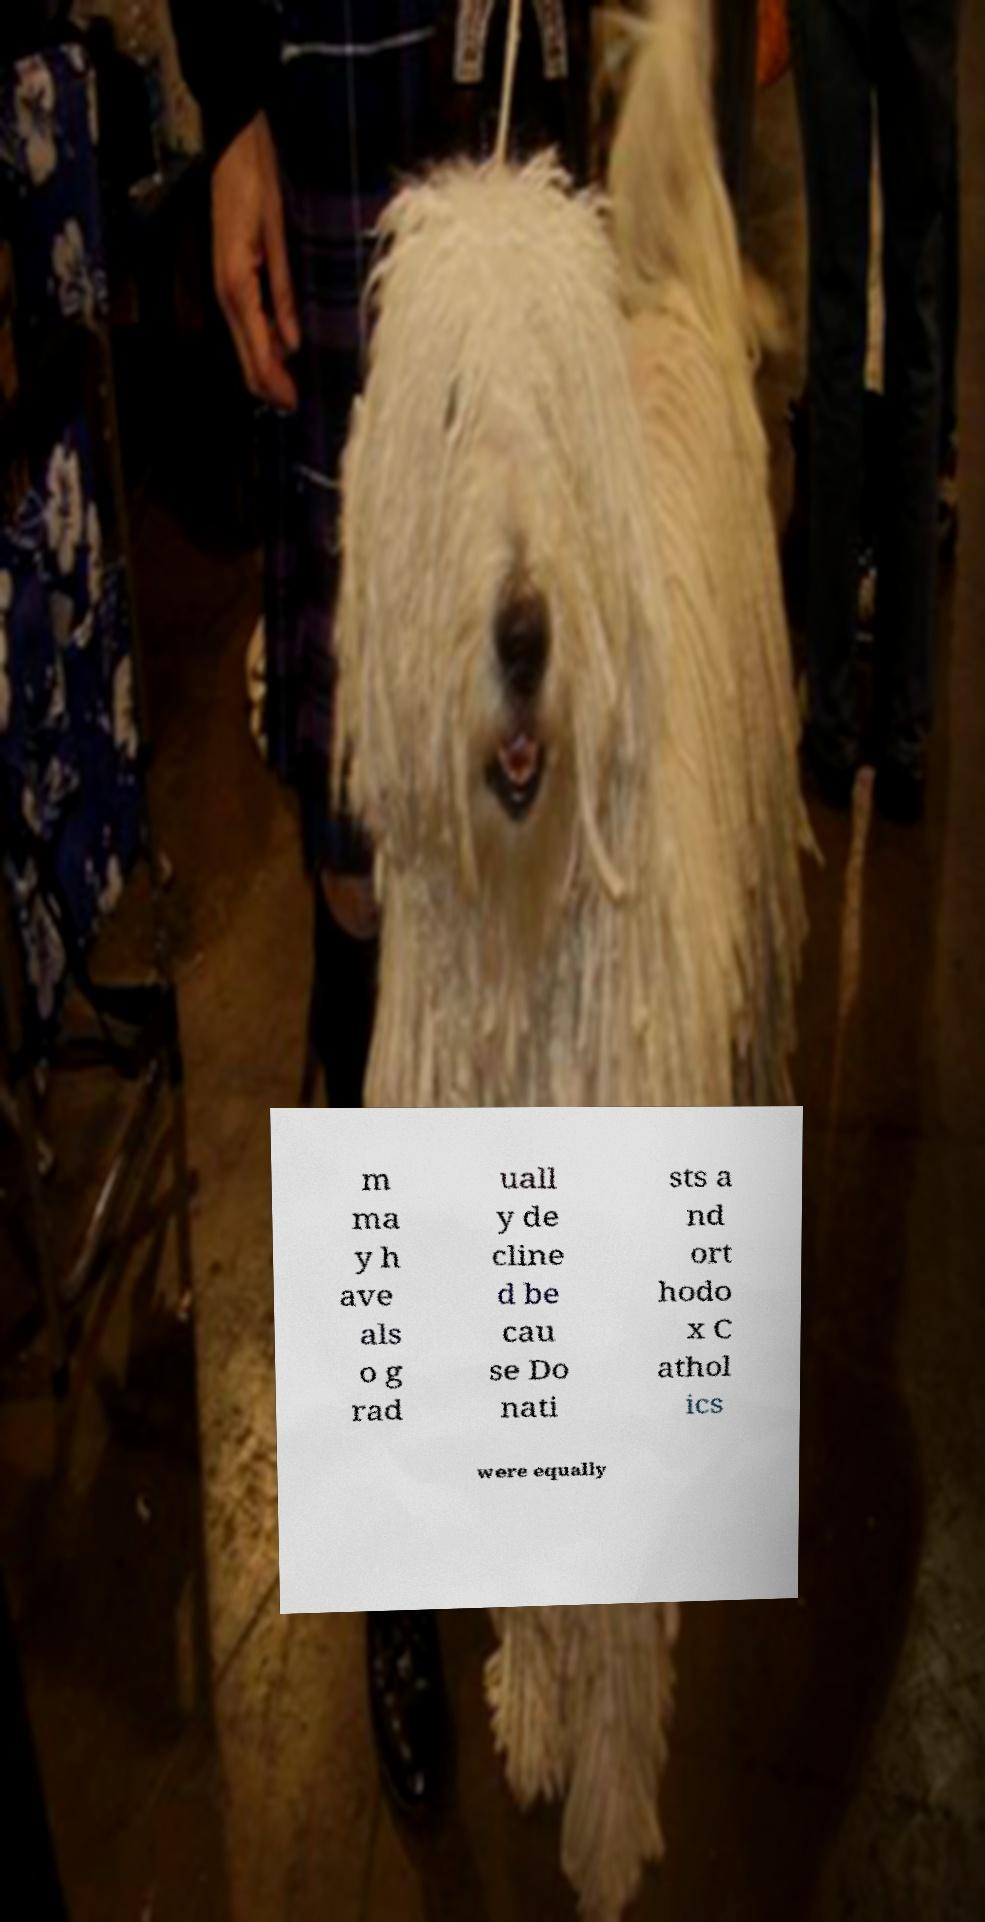Could you assist in decoding the text presented in this image and type it out clearly? m ma y h ave als o g rad uall y de cline d be cau se Do nati sts a nd ort hodo x C athol ics were equally 